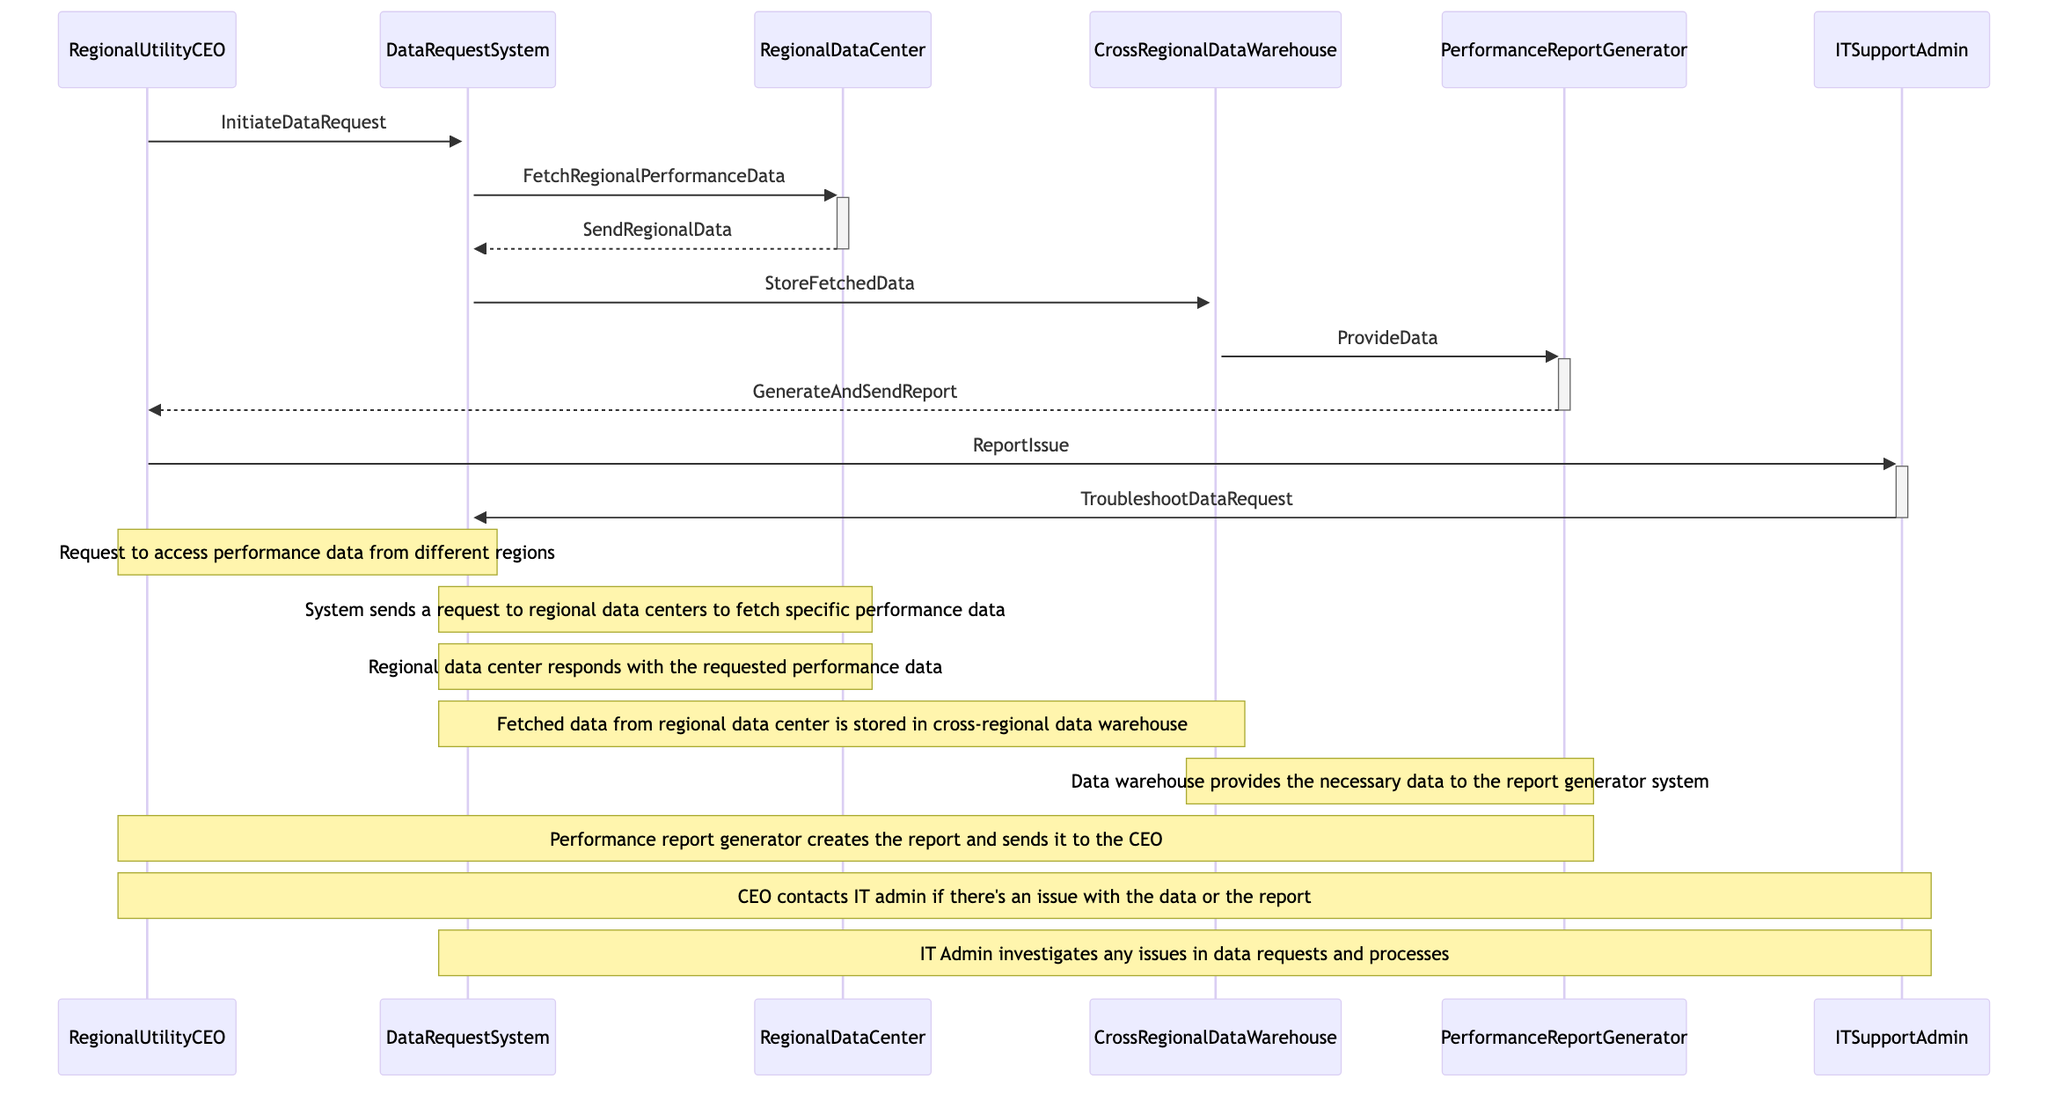What is the first action taken by the Regional Utility CEO? The first action taken by the Regional Utility CEO is to initiate a data request by sending a message to the Data Request System.
Answer: InitiateDataRequest How many distinct system components are involved in the sequence? The sequence diagram shows a total of five distinct system components, which are the Data Request System, Regional Data Center, Cross Regional Data Warehouse, Performance Report Generator, and IT Support Admin.
Answer: Five Which component responds to the Data Request System with the requested performance data? The component that responds to the Data Request System with the requested performance data is the Regional Data Center.
Answer: RegionalDataCenter What action occurs after the Data Request System stores fetched data? After storing the fetched data, the next action is that the Cross Regional Data Warehouse provides data to the Performance Report Generator.
Answer: ProvideData What does the CEO do if there's an issue with the data or the report? If there's an issue with the data or the report, the CEO contacts the IT Support Admin to report the issue.
Answer: ReportIssue How does IT Support Admin address issues with the data requests? The IT Support Admin addresses issues by troubleshooting the data request system to investigate any problems with data requests and processes.
Answer: TroubleshootDataRequest Which message indicates that the report has been generated and sent to the CEO? The message that indicates the report has been generated and sent to the CEO is called GenerateAndSendReport.
Answer: GenerateAndSendReport What is the final action in the sequence diagram? The final action in the sequence diagram is the IT Support Admin troubleshooting the data request system after the CEO reports an issue.
Answer: TroubleshootDataRequest Which two actors are involved in the report resolution process? The two actors involved in the report resolution process are the Regional Utility CEO and the IT Support Admin.
Answer: RegionalUtilityCEO, ITSupportAdmin What type of warehouse is involved in storing fetched data? The type of warehouse involved in storing fetched data is the Cross Regional Data Warehouse.
Answer: CrossRegionalDataWarehouse 